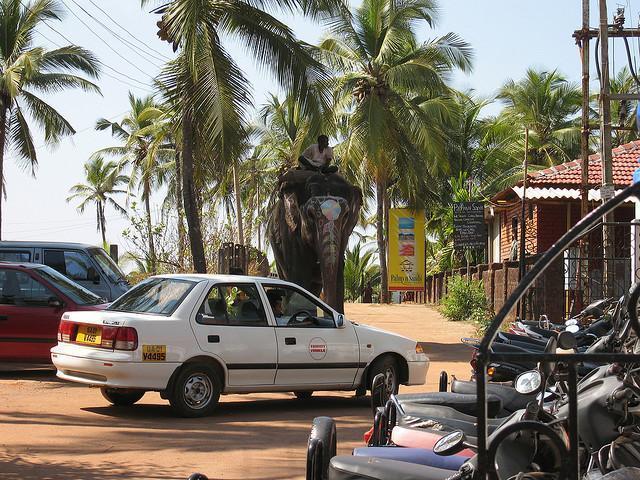What is this place?
From the following four choices, select the correct answer to address the question.
Options: Car dealer, subway, biker bar, walmart. Biker bar. 